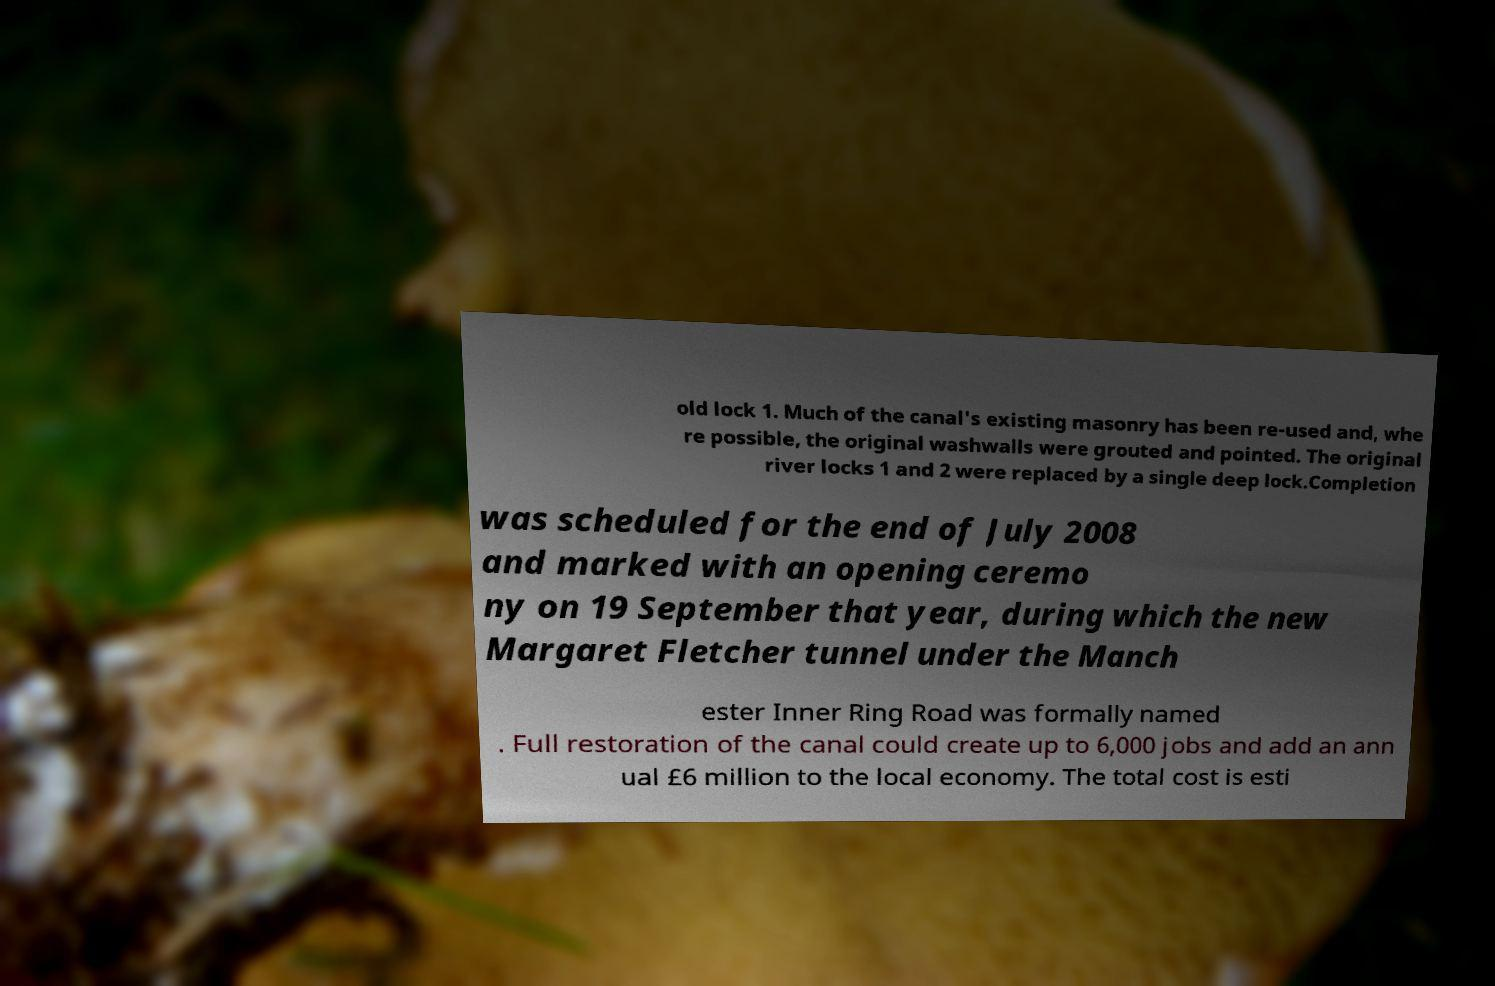Could you extract and type out the text from this image? old lock 1. Much of the canal's existing masonry has been re-used and, whe re possible, the original washwalls were grouted and pointed. The original river locks 1 and 2 were replaced by a single deep lock.Completion was scheduled for the end of July 2008 and marked with an opening ceremo ny on 19 September that year, during which the new Margaret Fletcher tunnel under the Manch ester Inner Ring Road was formally named . Full restoration of the canal could create up to 6,000 jobs and add an ann ual £6 million to the local economy. The total cost is esti 